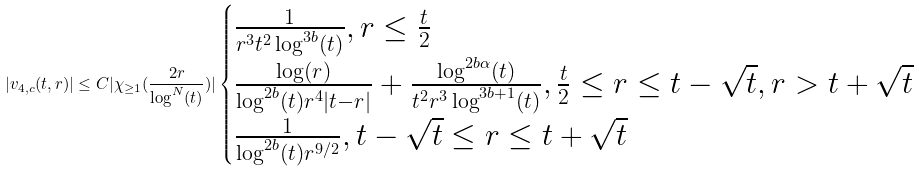Convert formula to latex. <formula><loc_0><loc_0><loc_500><loc_500>| v _ { 4 , c } ( t , r ) | \leq C | \chi _ { \geq 1 } ( \frac { 2 r } { \log ^ { N } ( t ) } ) | \begin{cases} \frac { 1 } { r ^ { 3 } t ^ { 2 } \log ^ { 3 b } ( t ) } , r \leq \frac { t } { 2 } \\ \frac { \log ( r ) } { \log ^ { 2 b } ( t ) r ^ { 4 } | t - r | } + \frac { \log ^ { 2 b \alpha } ( t ) } { t ^ { 2 } r ^ { 3 } \log ^ { 3 b + 1 } ( t ) } , \frac { t } { 2 } \leq r \leq t - \sqrt { t } , r > t + \sqrt { t } \\ \frac { 1 } { \log ^ { 2 b } ( t ) r ^ { 9 / 2 } } , t - \sqrt { t } \leq r \leq t + \sqrt { t } \end{cases}</formula> 